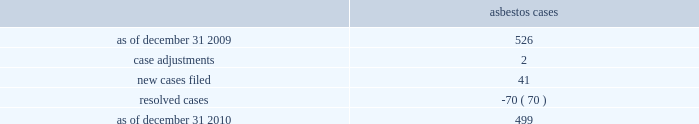Asbestos claims the company and several of its us subsidiaries are defendants in asbestos cases .
During the year ended december 31 , 2010 , asbestos case activity is as follows: .
Because many of these cases involve numerous plaintiffs , the company is subject to claims significantly in excess of the number of actual cases .
The company has reserves for defense costs related to claims arising from these matters .
Award proceedings in relation to domination agreement and squeeze-out on october 1 , 2004 , celanese gmbh and the company 2019s subsidiary , bcp holdings gmbh ( 201cbcp holdings 201d ) , a german limited liability company , entered into a domination agreement pursuant to which the bcp holdings became obligated to offer to acquire all outstanding celanese gmbh shares from the minority shareholders of celanese gmbh in return for payment of fair cash compensation ( the 201cpurchaser offer 201d ) .
The amount of this fair cash compensation was determined to be a41.92 per share in accordance with applicable german law .
All minority shareholders who elected not to sell their shares to the bcp holdings under the purchaser offer were entitled to remain shareholders of celanese gmbh and to receive from the bcp holdings a gross guaranteed annual payment of a3.27 per celanese gmbh share less certain corporate taxes in lieu of any dividend .
As of march 30 , 2005 , several minority shareholders of celanese gmbh had initiated special award proceedings seeking the court 2019s review of the amounts of the fair cash compensation and of the guaranteed annual payment offered in the purchaser offer under the domination agreement .
In the purchaser offer , 145387 shares were tendered at the fair cash compensation of a41.92 , and 924078 shares initially remained outstanding and were entitled to the guaranteed annual payment under the domination agreement .
As a result of these proceedings , the amount of the fair cash consideration and the guaranteed annual payment paid under the domination agreement could be increased by the court so that all minority shareholders , including those who have already tendered their shares in the purchaser offer for the fair cash compensation , could claim the respective higher amounts .
On december 12 , 2006 , the court of first instance appointed an expert to assist the court in determining the value of celanese gmbh .
On may 30 , 2006 the majority shareholder of celanese gmbh adopted a squeeze-out resolution under which all outstanding shares held by minority shareholders should be transferred to bcp holdings for a fair cash compensation of a66.99 per share ( the 201csqueeze-out 201d ) .
This shareholder resolution was challenged by shareholders but the squeeze-out became effective after the disputes were settled on december 22 , 2006 .
Award proceedings were subsequently filed by 79 shareholders against bcp holdings with the frankfurt district court requesting the court to set a higher amount for the squeeze-out compensation .
Pursuant to a settlement agreement between bcp holdings and certain former celanese gmbh shareholders , if the court sets a higher value for the fair cash compensation or the guaranteed payment under the purchaser offer or the squeeze-out compensation , former celanese gmbh shareholders who ceased to be shareholders of celanese gmbh due to the squeeze-out will be entitled to claim for their shares the higher of the compensation amounts determined by the court in these different proceedings related to the purchaser offer and the squeeze-out .
If the fair cash compensation determined by the court is higher than the squeeze-out compensation of a 66.99 , then 1069465 shares will be entitled to an adjustment .
If the court confirms the value of the fair cash compensation under the domination agreement but determines a higher value for the squeeze-out compensation , 924078 shares %%transmsg*** transmitting job : d77691 pcn : 148000000 ***%%pcmsg|148 |00010|yes|no|02/08/2011 16:10|0|0|page is valid , no graphics -- color : n| .
In 2010 what was the percentage decline in the asbestos cases from 2009? 
Computations: ((499 - 526) / 526)
Answer: -0.05133. 